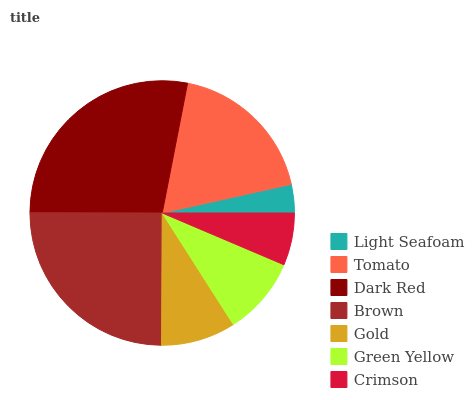Is Light Seafoam the minimum?
Answer yes or no. Yes. Is Dark Red the maximum?
Answer yes or no. Yes. Is Tomato the minimum?
Answer yes or no. No. Is Tomato the maximum?
Answer yes or no. No. Is Tomato greater than Light Seafoam?
Answer yes or no. Yes. Is Light Seafoam less than Tomato?
Answer yes or no. Yes. Is Light Seafoam greater than Tomato?
Answer yes or no. No. Is Tomato less than Light Seafoam?
Answer yes or no. No. Is Green Yellow the high median?
Answer yes or no. Yes. Is Green Yellow the low median?
Answer yes or no. Yes. Is Light Seafoam the high median?
Answer yes or no. No. Is Tomato the low median?
Answer yes or no. No. 